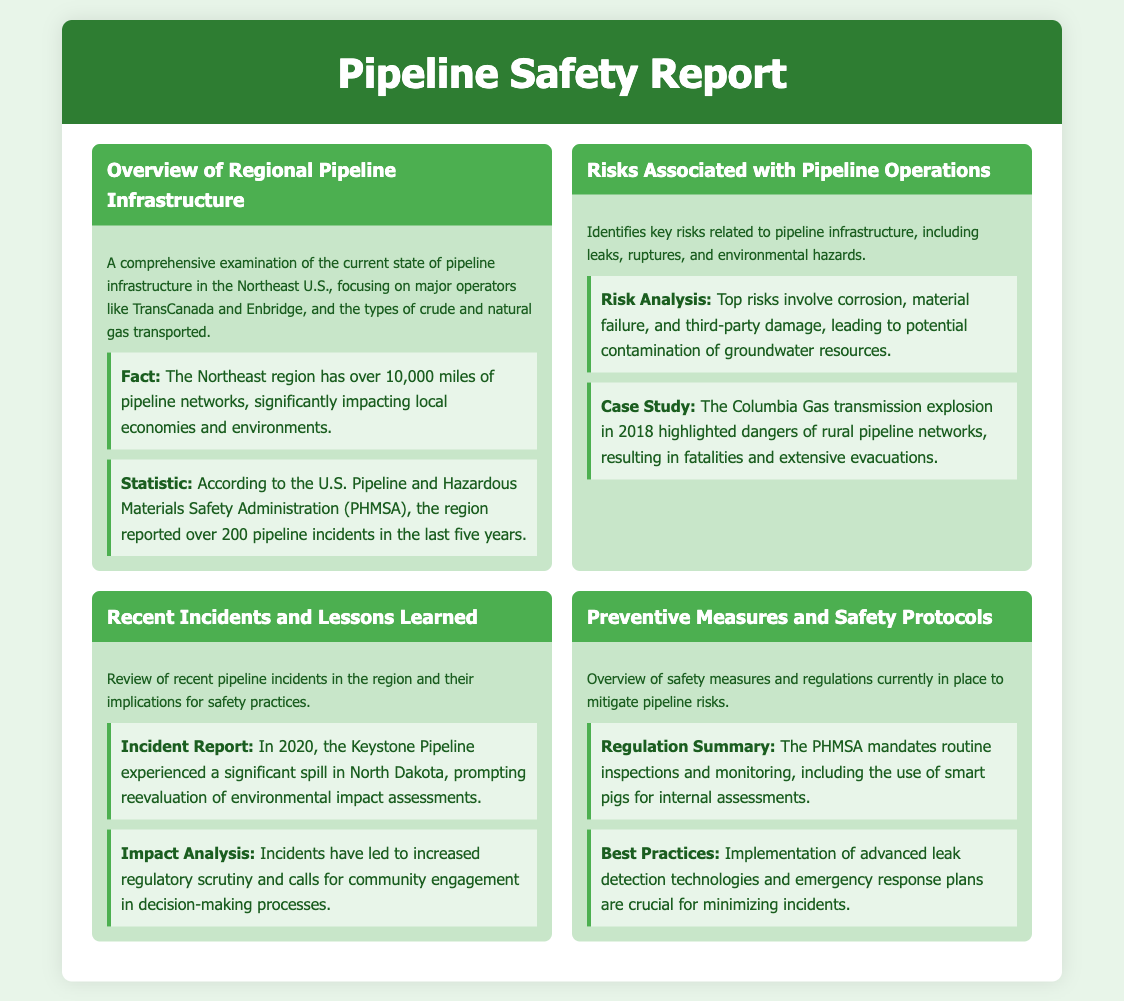What is the total length of pipeline networks in the Northeast region? The document states that the Northeast region has over 10,000 miles of pipeline networks.
Answer: over 10,000 miles How many pipeline incidents were reported in the last five years? According to the U.S. Pipeline and Hazardous Materials Safety Administration, the region reported over 200 pipeline incidents in the last five years.
Answer: over 200 What was highlighted by the Columbia Gas transmission explosion in 2018? The Columbia Gas transmission explosion in 2018 highlighted dangers of rural pipeline networks.
Answer: dangers of rural pipeline networks What incident occurred in North Dakota in 2020? In 2020, the Keystone Pipeline experienced a significant spill in North Dakota.
Answer: significant spill What is one of the regulations mandated by PHMSA? The PHMSA mandates routine inspections and monitoring, including the use of smart pigs for internal assessments.
Answer: smart pigs What advanced technology is mentioned for leak detection? Implementation of advanced leak detection technologies is crucial for minimizing incidents.
Answer: advanced leak detection technologies What are potential environmental hazards associated with pipeline operations? Key risks related to pipeline operations include leaks, ruptures, and environmental hazards.
Answer: leaks, ruptures, environmental hazards Which major operators are mentioned in the pipeline infrastructure overview? The document mentions major operators like TransCanada and Enbridge in the overview.
Answer: TransCanada and Enbridge 